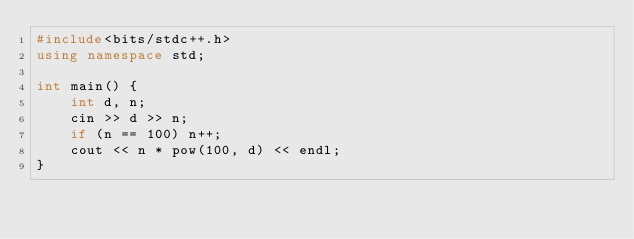Convert code to text. <code><loc_0><loc_0><loc_500><loc_500><_C++_>#include<bits/stdc++.h>
using namespace std;

int main() {
    int d, n;
    cin >> d >> n;
    if (n == 100) n++;
    cout << n * pow(100, d) << endl;
}
</code> 